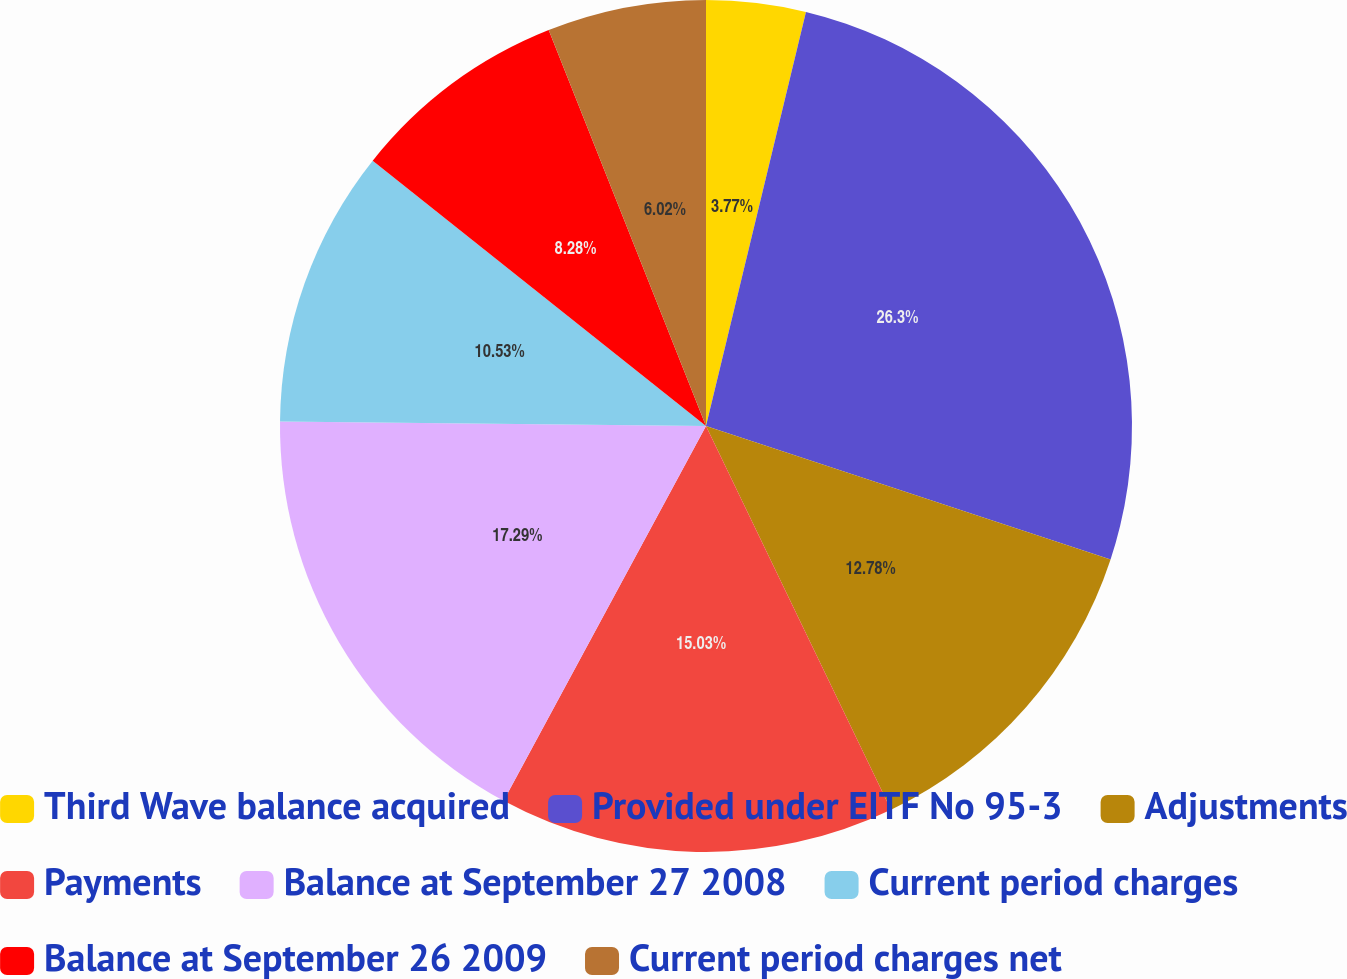<chart> <loc_0><loc_0><loc_500><loc_500><pie_chart><fcel>Third Wave balance acquired<fcel>Provided under EITF No 95-3<fcel>Adjustments<fcel>Payments<fcel>Balance at September 27 2008<fcel>Current period charges<fcel>Balance at September 26 2009<fcel>Current period charges net<nl><fcel>3.77%<fcel>26.3%<fcel>12.78%<fcel>15.03%<fcel>17.29%<fcel>10.53%<fcel>8.28%<fcel>6.02%<nl></chart> 